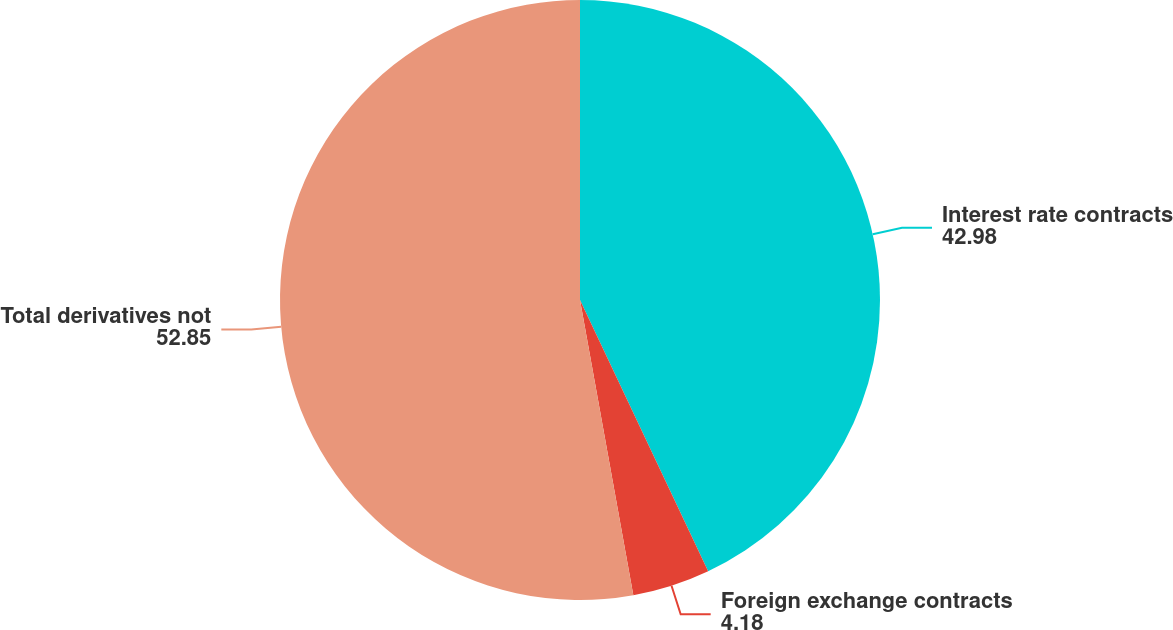<chart> <loc_0><loc_0><loc_500><loc_500><pie_chart><fcel>Interest rate contracts<fcel>Foreign exchange contracts<fcel>Total derivatives not<nl><fcel>42.98%<fcel>4.18%<fcel>52.85%<nl></chart> 